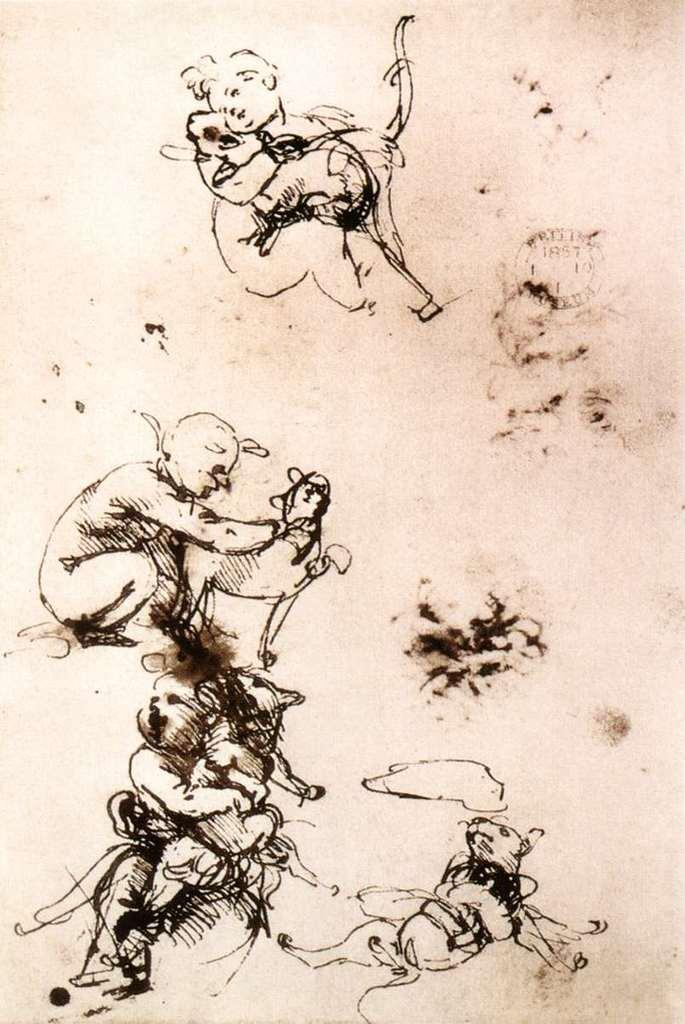What is the main subject of the image? The main subject of the image is a drawing. What is depicted in the drawing? The drawing contains a person and an animal. What type of lamp is shown in the drawing? There is no lamp present in the drawing; it only contains a person and an animal. 